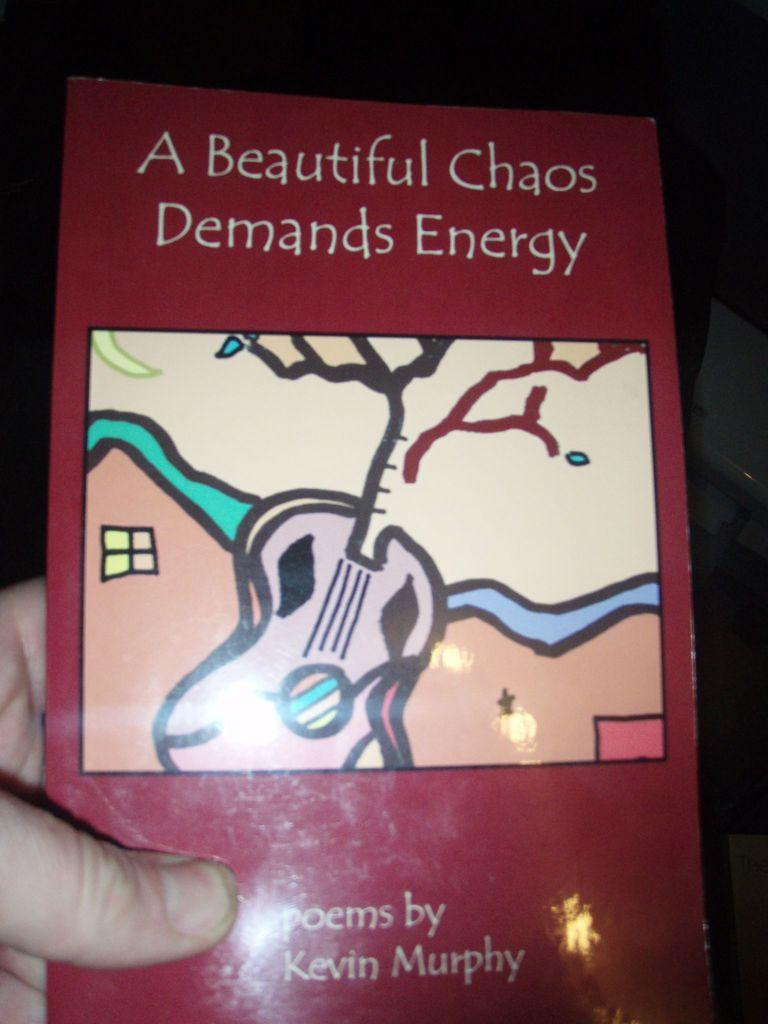Provide a one-sentence caption for the provided image. hand holding red book with title a beautiful chaos demands energy. 